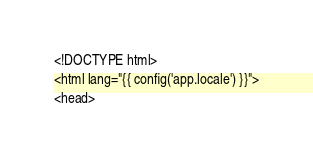Convert code to text. <code><loc_0><loc_0><loc_500><loc_500><_PHP_><!DOCTYPE html>
<html lang="{{ config('app.locale') }}">
<head></code> 